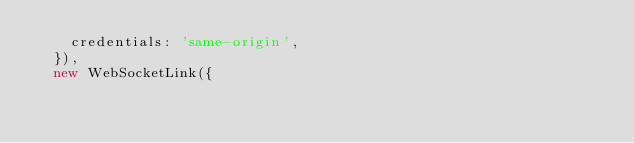Convert code to text. <code><loc_0><loc_0><loc_500><loc_500><_TypeScript_>    credentials: 'same-origin',
  }),
  new WebSocketLink({</code> 